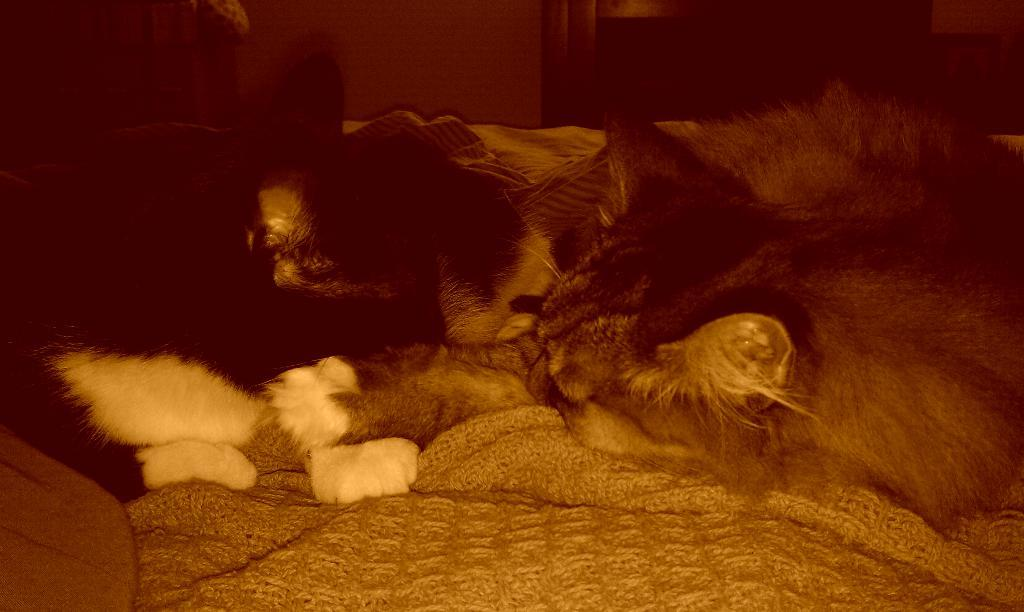What type of living creature is present in the image? There is an animal in the image. What theory does the animal in the image support? There is no theory mentioned or implied in the image, as it only features an animal. 